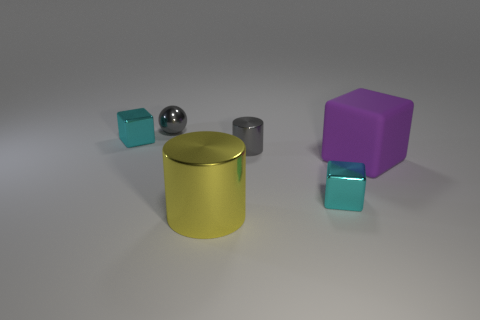What is the size of the thing that is left of the gray shiny sphere?
Provide a short and direct response. Small. What is the shape of the yellow thing that is the same material as the gray cylinder?
Ensure brevity in your answer.  Cylinder. Are there any other things of the same color as the big shiny cylinder?
Keep it short and to the point. No. What is the color of the small cube that is on the left side of the tiny gray thing that is in front of the small gray sphere?
Your answer should be compact. Cyan. How many small things are rubber objects or shiny things?
Your answer should be compact. 4. What material is the tiny gray object that is the same shape as the big yellow metal thing?
Give a very brief answer. Metal. Is there any other thing that has the same material as the large purple thing?
Ensure brevity in your answer.  No. The small ball is what color?
Offer a terse response. Gray. Is the color of the tiny metal cylinder the same as the sphere?
Give a very brief answer. Yes. What number of tiny cyan objects are on the right side of the gray cylinder that is behind the big purple rubber object?
Make the answer very short. 1. 